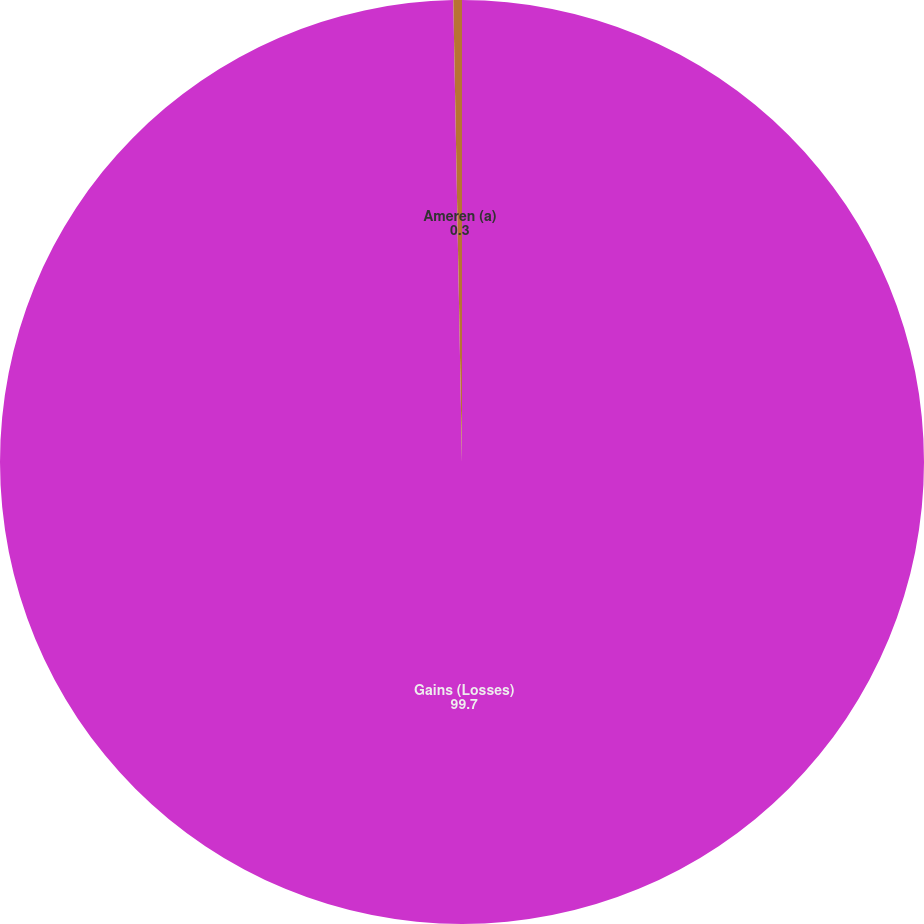Convert chart. <chart><loc_0><loc_0><loc_500><loc_500><pie_chart><fcel>Gains (Losses)<fcel>Ameren (a)<nl><fcel>99.7%<fcel>0.3%<nl></chart> 